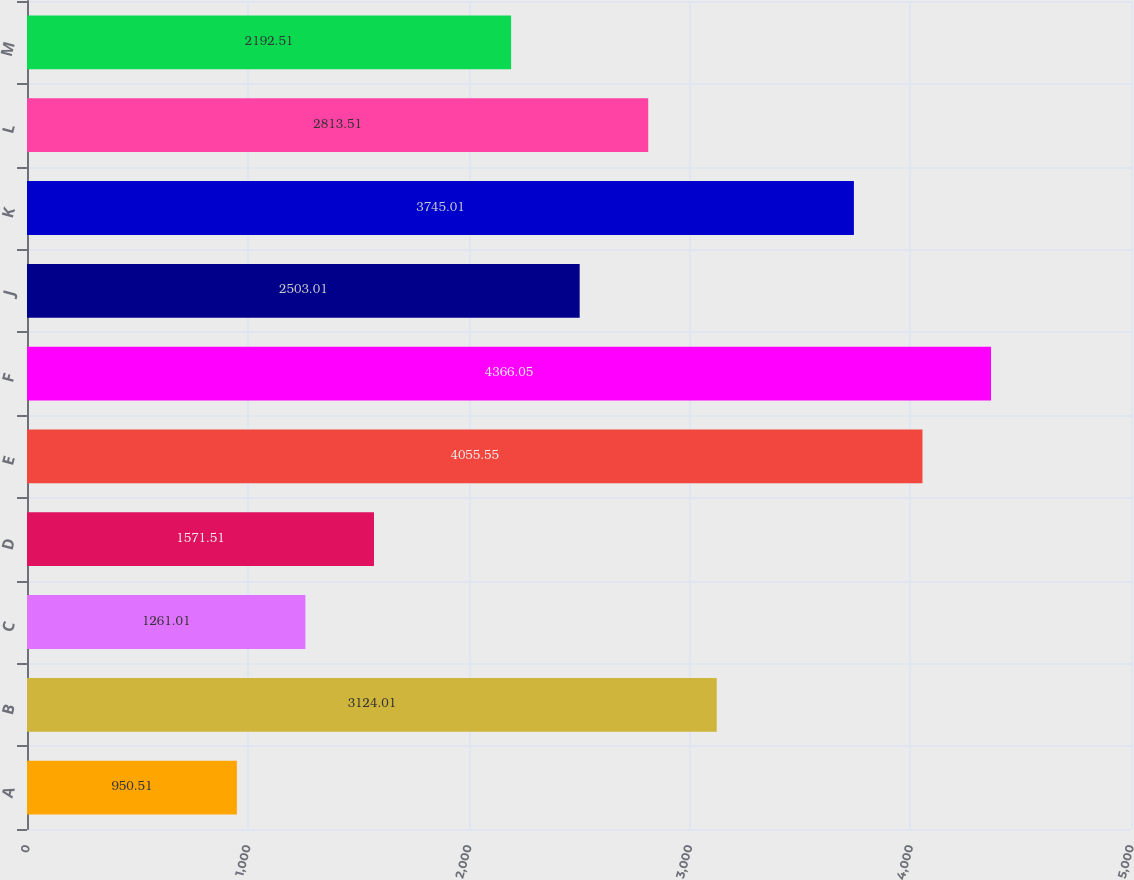<chart> <loc_0><loc_0><loc_500><loc_500><bar_chart><fcel>A<fcel>B<fcel>C<fcel>D<fcel>E<fcel>F<fcel>J<fcel>K<fcel>L<fcel>M<nl><fcel>950.51<fcel>3124.01<fcel>1261.01<fcel>1571.51<fcel>4055.55<fcel>4366.05<fcel>2503.01<fcel>3745.01<fcel>2813.51<fcel>2192.51<nl></chart> 